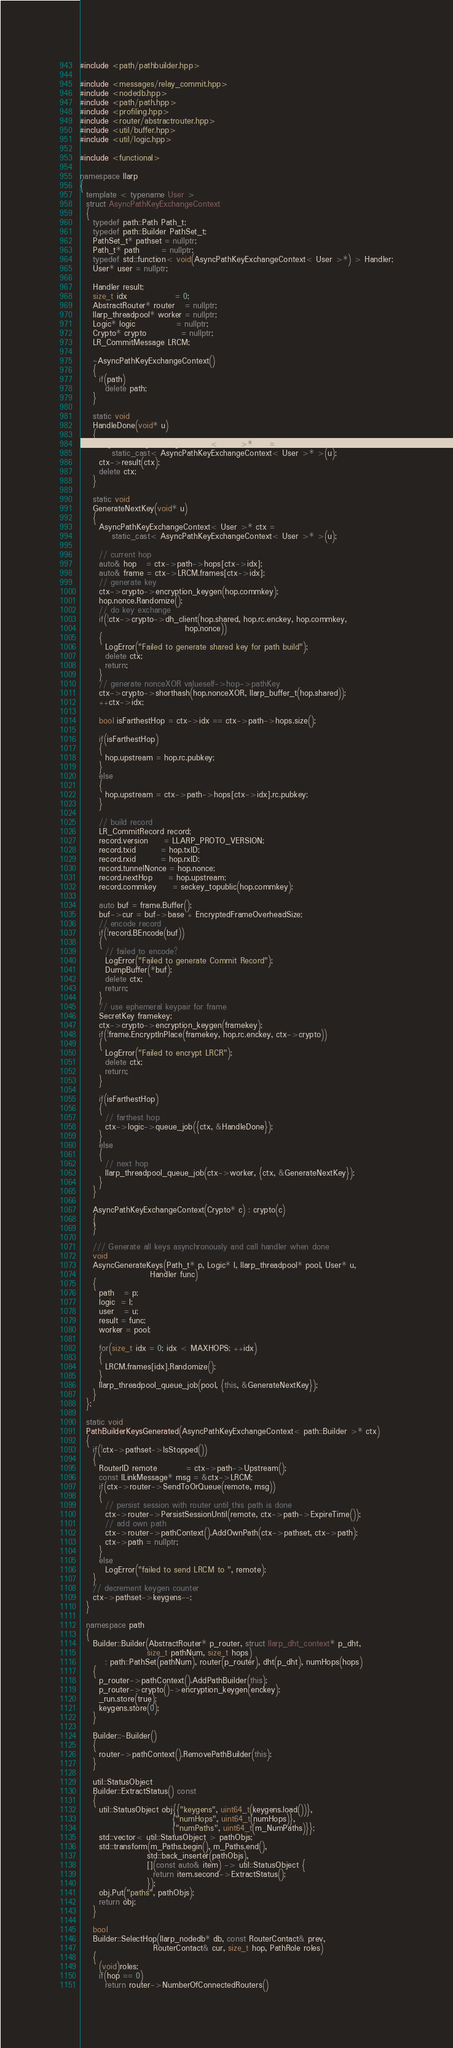Convert code to text. <code><loc_0><loc_0><loc_500><loc_500><_C++_>#include <path/pathbuilder.hpp>

#include <messages/relay_commit.hpp>
#include <nodedb.hpp>
#include <path/path.hpp>
#include <profiling.hpp>
#include <router/abstractrouter.hpp>
#include <util/buffer.hpp>
#include <util/logic.hpp>

#include <functional>

namespace llarp
{
  template < typename User >
  struct AsyncPathKeyExchangeContext
  {
    typedef path::Path Path_t;
    typedef path::Builder PathSet_t;
    PathSet_t* pathset = nullptr;
    Path_t* path       = nullptr;
    typedef std::function< void(AsyncPathKeyExchangeContext< User >*) > Handler;
    User* user = nullptr;

    Handler result;
    size_t idx               = 0;
    AbstractRouter* router   = nullptr;
    llarp_threadpool* worker = nullptr;
    Logic* logic             = nullptr;
    Crypto* crypto           = nullptr;
    LR_CommitMessage LRCM;

    ~AsyncPathKeyExchangeContext()
    {
      if(path)
        delete path;
    }

    static void
    HandleDone(void* u)
    {
      AsyncPathKeyExchangeContext< User >* ctx =
          static_cast< AsyncPathKeyExchangeContext< User >* >(u);
      ctx->result(ctx);
      delete ctx;
    }

    static void
    GenerateNextKey(void* u)
    {
      AsyncPathKeyExchangeContext< User >* ctx =
          static_cast< AsyncPathKeyExchangeContext< User >* >(u);

      // current hop
      auto& hop   = ctx->path->hops[ctx->idx];
      auto& frame = ctx->LRCM.frames[ctx->idx];
      // generate key
      ctx->crypto->encryption_keygen(hop.commkey);
      hop.nonce.Randomize();
      // do key exchange
      if(!ctx->crypto->dh_client(hop.shared, hop.rc.enckey, hop.commkey,
                                 hop.nonce))
      {
        LogError("Failed to generate shared key for path build");
        delete ctx;
        return;
      }
      // generate nonceXOR valueself->hop->pathKey
      ctx->crypto->shorthash(hop.nonceXOR, llarp_buffer_t(hop.shared));
      ++ctx->idx;

      bool isFarthestHop = ctx->idx == ctx->path->hops.size();

      if(isFarthestHop)
      {
        hop.upstream = hop.rc.pubkey;
      }
      else
      {
        hop.upstream = ctx->path->hops[ctx->idx].rc.pubkey;
      }

      // build record
      LR_CommitRecord record;
      record.version     = LLARP_PROTO_VERSION;
      record.txid        = hop.txID;
      record.rxid        = hop.rxID;
      record.tunnelNonce = hop.nonce;
      record.nextHop     = hop.upstream;
      record.commkey     = seckey_topublic(hop.commkey);

      auto buf = frame.Buffer();
      buf->cur = buf->base + EncryptedFrameOverheadSize;
      // encode record
      if(!record.BEncode(buf))
      {
        // failed to encode?
        LogError("Failed to generate Commit Record");
        DumpBuffer(*buf);
        delete ctx;
        return;
      }
      // use ephemeral keypair for frame
      SecretKey framekey;
      ctx->crypto->encryption_keygen(framekey);
      if(!frame.EncryptInPlace(framekey, hop.rc.enckey, ctx->crypto))
      {
        LogError("Failed to encrypt LRCR");
        delete ctx;
        return;
      }

      if(isFarthestHop)
      {
        // farthest hop
        ctx->logic->queue_job({ctx, &HandleDone});
      }
      else
      {
        // next hop
        llarp_threadpool_queue_job(ctx->worker, {ctx, &GenerateNextKey});
      }
    }

    AsyncPathKeyExchangeContext(Crypto* c) : crypto(c)
    {
    }

    /// Generate all keys asynchronously and call handler when done
    void
    AsyncGenerateKeys(Path_t* p, Logic* l, llarp_threadpool* pool, User* u,
                      Handler func)
    {
      path   = p;
      logic  = l;
      user   = u;
      result = func;
      worker = pool;

      for(size_t idx = 0; idx < MAXHOPS; ++idx)
      {
        LRCM.frames[idx].Randomize();
      }
      llarp_threadpool_queue_job(pool, {this, &GenerateNextKey});
    }
  };

  static void
  PathBuilderKeysGenerated(AsyncPathKeyExchangeContext< path::Builder >* ctx)
  {
    if(!ctx->pathset->IsStopped())
    {
      RouterID remote         = ctx->path->Upstream();
      const ILinkMessage* msg = &ctx->LRCM;
      if(ctx->router->SendToOrQueue(remote, msg))
      {
        // persist session with router until this path is done
        ctx->router->PersistSessionUntil(remote, ctx->path->ExpireTime());
        // add own path
        ctx->router->pathContext().AddOwnPath(ctx->pathset, ctx->path);
        ctx->path = nullptr;
      }
      else
        LogError("failed to send LRCM to ", remote);
    }
    // decrement keygen counter
    ctx->pathset->keygens--;
  }

  namespace path
  {
    Builder::Builder(AbstractRouter* p_router, struct llarp_dht_context* p_dht,
                     size_t pathNum, size_t hops)
        : path::PathSet(pathNum), router(p_router), dht(p_dht), numHops(hops)
    {
      p_router->pathContext().AddPathBuilder(this);
      p_router->crypto()->encryption_keygen(enckey);
      _run.store(true);
      keygens.store(0);
    }

    Builder::~Builder()
    {
      router->pathContext().RemovePathBuilder(this);
    }

    util::StatusObject
    Builder::ExtractStatus() const
    {
      util::StatusObject obj{{"keygens", uint64_t(keygens.load())},
                             {"numHops", uint64_t(numHops)},
                             {"numPaths", uint64_t(m_NumPaths)}};
      std::vector< util::StatusObject > pathObjs;
      std::transform(m_Paths.begin(), m_Paths.end(),
                     std::back_inserter(pathObjs),
                     [](const auto& item) -> util::StatusObject {
                       return item.second->ExtractStatus();
                     });
      obj.Put("paths", pathObjs);
      return obj;
    }

    bool
    Builder::SelectHop(llarp_nodedb* db, const RouterContact& prev,
                       RouterContact& cur, size_t hop, PathRole roles)
    {
      (void)roles;
      if(hop == 0)
        return router->NumberOfConnectedRouters()</code> 